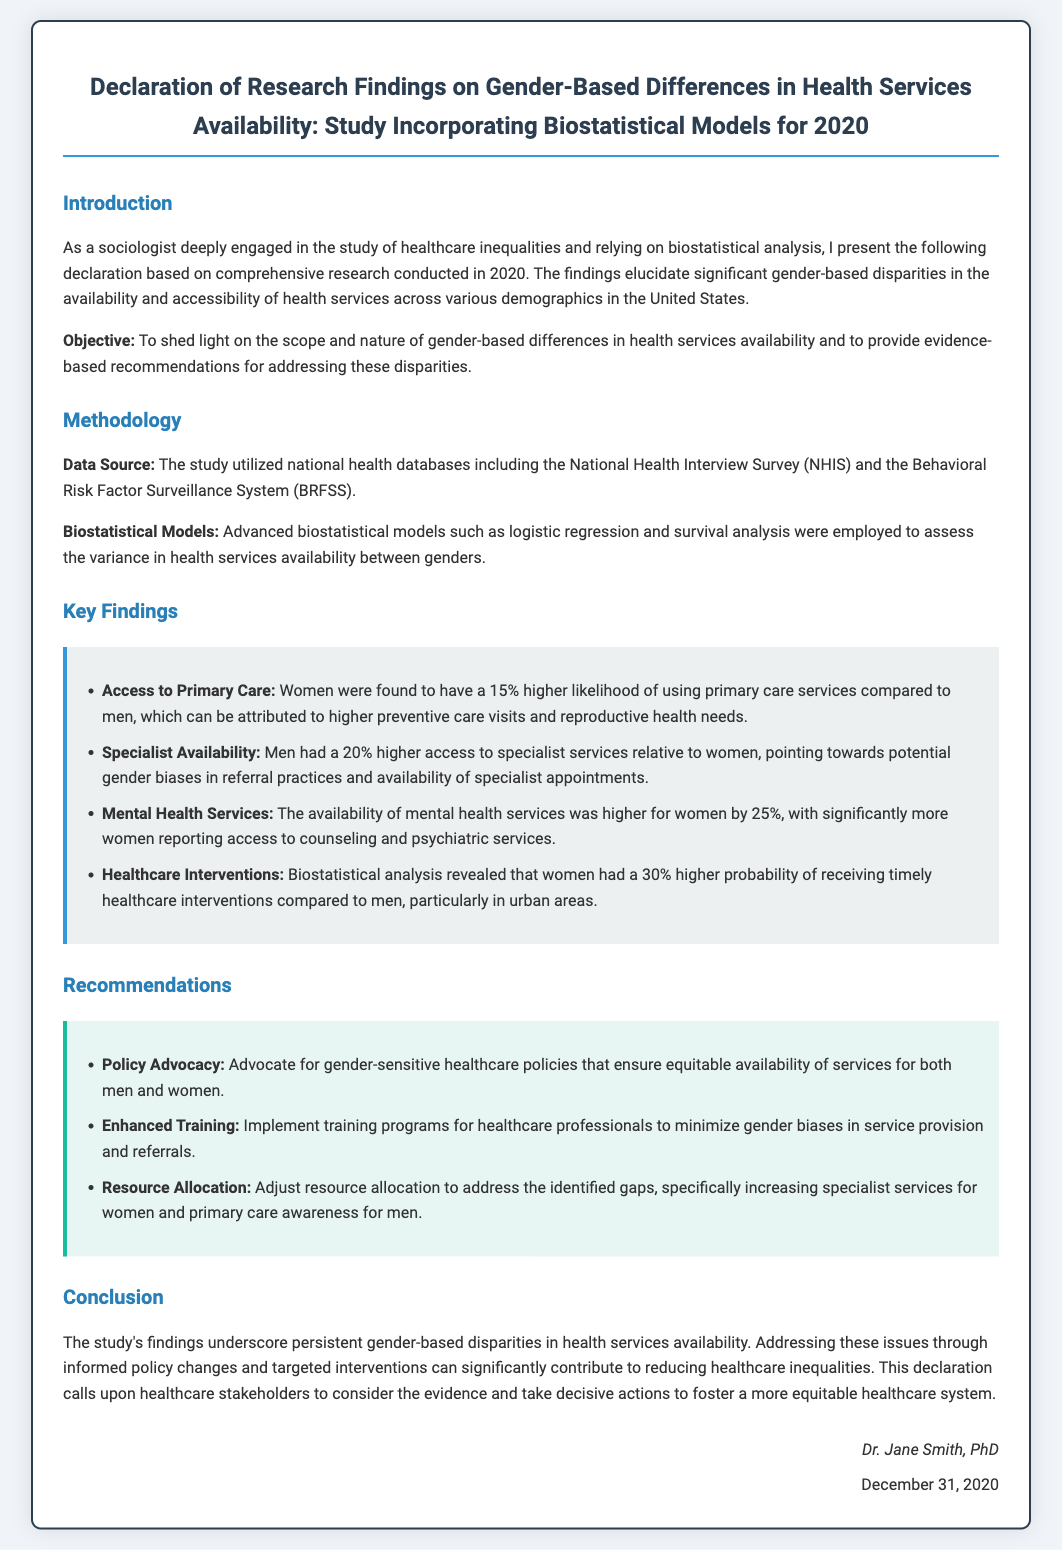what is the title of the document? The title of the document is stated at the top and provides a comprehensive view of the research focus.
Answer: Declaration of Research Findings on Gender-Based Differences in Health Services Availability: Study Incorporating Biostatistical Models for 2020 who is the author of the declaration? The author is mentioned in the signature section at the bottom of the document, indicating who created the declaration.
Answer: Dr. Jane Smith, PhD what is the probability increase for women receiving timely healthcare interventions? This figure is found in the key findings section and highlights a specific statistic related to healthcare interventions.
Answer: 30% which database was utilized for data source in the study? The source of data is specified in the methodology section of the document, providing insight into the data collection process.
Answer: National Health Interview Survey (NHIS) and the Behavioral Risk Factor Surveillance System (BRFSS) what is one of the recommendations made in the document? Recommendations are provided in a specific section, aiming to address the identified disparities in services.
Answer: Advocate for gender-sensitive healthcare policies how much higher was women's access to mental health services compared to men? The key findings give a comparative analysis regarding different health services access related to gender.
Answer: 25% what research methodology was employed in the study? Methodology is clearly outlined in the corresponding section, indicating the approach taken for the research.
Answer: Biostatistical Models what date was the declaration signed? The signed date is located at the bottom of the document, providing a timestamp for the declaration.
Answer: December 31, 2020 